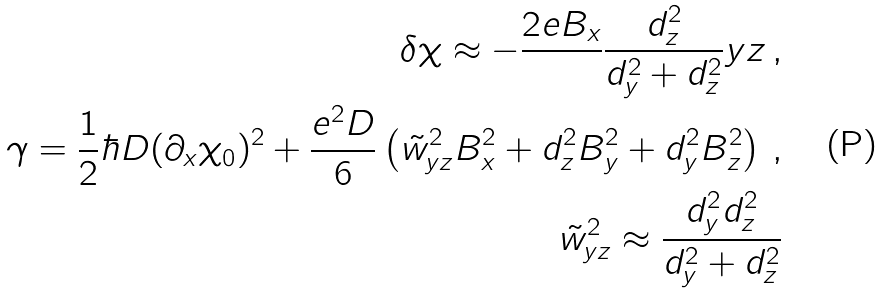Convert formula to latex. <formula><loc_0><loc_0><loc_500><loc_500>\delta \chi \approx - \frac { 2 e B _ { x } } { } \frac { d _ { z } ^ { 2 } } { d _ { y } ^ { 2 } + d _ { z } ^ { 2 } } y z \, , \\ \gamma = \frac { 1 } { 2 } \hbar { D } ( \partial _ { x } \chi _ { 0 } ) ^ { 2 } + \frac { e ^ { 2 } D } { 6 } \left ( \tilde { w } _ { y z } ^ { 2 } B _ { x } ^ { 2 } + d _ { z } ^ { 2 } B _ { y } ^ { 2 } + d _ { y } ^ { 2 } B _ { z } ^ { 2 } \right ) \, , \\ \tilde { w } _ { y z } ^ { 2 } \approx \frac { d _ { y } ^ { 2 } d _ { z } ^ { 2 } } { d _ { y } ^ { 2 } + d _ { z } ^ { 2 } }</formula> 